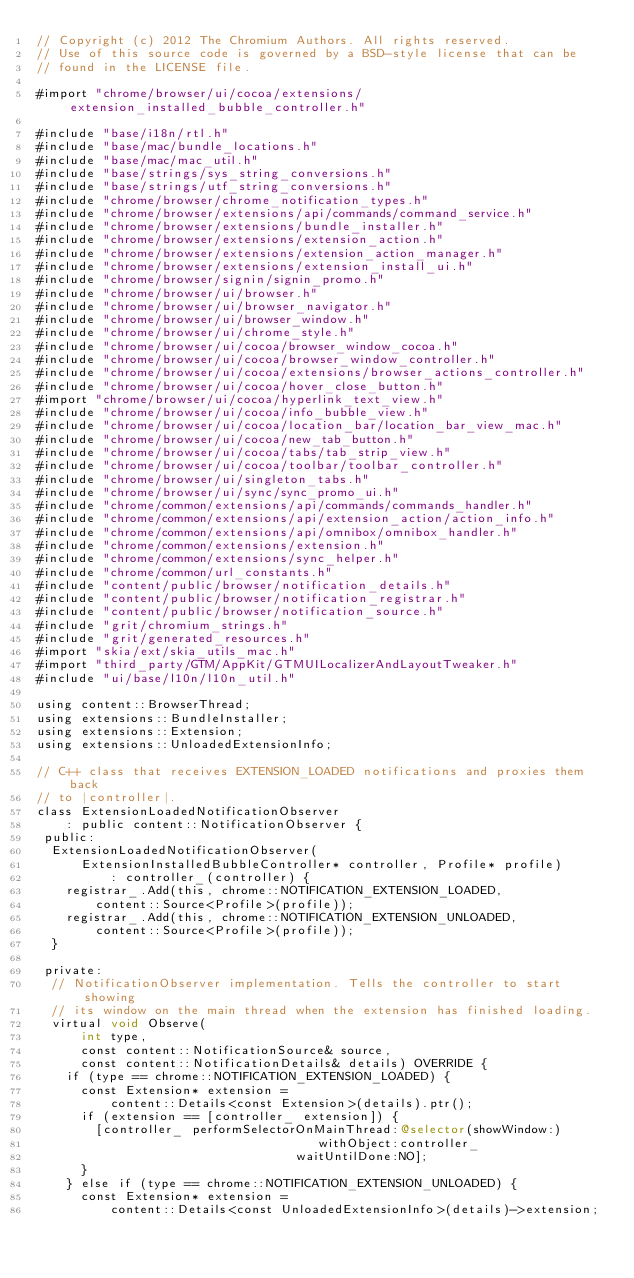Convert code to text. <code><loc_0><loc_0><loc_500><loc_500><_ObjectiveC_>// Copyright (c) 2012 The Chromium Authors. All rights reserved.
// Use of this source code is governed by a BSD-style license that can be
// found in the LICENSE file.

#import "chrome/browser/ui/cocoa/extensions/extension_installed_bubble_controller.h"

#include "base/i18n/rtl.h"
#include "base/mac/bundle_locations.h"
#include "base/mac/mac_util.h"
#include "base/strings/sys_string_conversions.h"
#include "base/strings/utf_string_conversions.h"
#include "chrome/browser/chrome_notification_types.h"
#include "chrome/browser/extensions/api/commands/command_service.h"
#include "chrome/browser/extensions/bundle_installer.h"
#include "chrome/browser/extensions/extension_action.h"
#include "chrome/browser/extensions/extension_action_manager.h"
#include "chrome/browser/extensions/extension_install_ui.h"
#include "chrome/browser/signin/signin_promo.h"
#include "chrome/browser/ui/browser.h"
#include "chrome/browser/ui/browser_navigator.h"
#include "chrome/browser/ui/browser_window.h"
#include "chrome/browser/ui/chrome_style.h"
#include "chrome/browser/ui/cocoa/browser_window_cocoa.h"
#include "chrome/browser/ui/cocoa/browser_window_controller.h"
#include "chrome/browser/ui/cocoa/extensions/browser_actions_controller.h"
#include "chrome/browser/ui/cocoa/hover_close_button.h"
#import "chrome/browser/ui/cocoa/hyperlink_text_view.h"
#include "chrome/browser/ui/cocoa/info_bubble_view.h"
#include "chrome/browser/ui/cocoa/location_bar/location_bar_view_mac.h"
#include "chrome/browser/ui/cocoa/new_tab_button.h"
#include "chrome/browser/ui/cocoa/tabs/tab_strip_view.h"
#include "chrome/browser/ui/cocoa/toolbar/toolbar_controller.h"
#include "chrome/browser/ui/singleton_tabs.h"
#include "chrome/browser/ui/sync/sync_promo_ui.h"
#include "chrome/common/extensions/api/commands/commands_handler.h"
#include "chrome/common/extensions/api/extension_action/action_info.h"
#include "chrome/common/extensions/api/omnibox/omnibox_handler.h"
#include "chrome/common/extensions/extension.h"
#include "chrome/common/extensions/sync_helper.h"
#include "chrome/common/url_constants.h"
#include "content/public/browser/notification_details.h"
#include "content/public/browser/notification_registrar.h"
#include "content/public/browser/notification_source.h"
#include "grit/chromium_strings.h"
#include "grit/generated_resources.h"
#import "skia/ext/skia_utils_mac.h"
#import "third_party/GTM/AppKit/GTMUILocalizerAndLayoutTweaker.h"
#include "ui/base/l10n/l10n_util.h"

using content::BrowserThread;
using extensions::BundleInstaller;
using extensions::Extension;
using extensions::UnloadedExtensionInfo;

// C++ class that receives EXTENSION_LOADED notifications and proxies them back
// to |controller|.
class ExtensionLoadedNotificationObserver
    : public content::NotificationObserver {
 public:
  ExtensionLoadedNotificationObserver(
      ExtensionInstalledBubbleController* controller, Profile* profile)
          : controller_(controller) {
    registrar_.Add(this, chrome::NOTIFICATION_EXTENSION_LOADED,
        content::Source<Profile>(profile));
    registrar_.Add(this, chrome::NOTIFICATION_EXTENSION_UNLOADED,
        content::Source<Profile>(profile));
  }

 private:
  // NotificationObserver implementation. Tells the controller to start showing
  // its window on the main thread when the extension has finished loading.
  virtual void Observe(
      int type,
      const content::NotificationSource& source,
      const content::NotificationDetails& details) OVERRIDE {
    if (type == chrome::NOTIFICATION_EXTENSION_LOADED) {
      const Extension* extension =
          content::Details<const Extension>(details).ptr();
      if (extension == [controller_ extension]) {
        [controller_ performSelectorOnMainThread:@selector(showWindow:)
                                      withObject:controller_
                                   waitUntilDone:NO];
      }
    } else if (type == chrome::NOTIFICATION_EXTENSION_UNLOADED) {
      const Extension* extension =
          content::Details<const UnloadedExtensionInfo>(details)->extension;</code> 